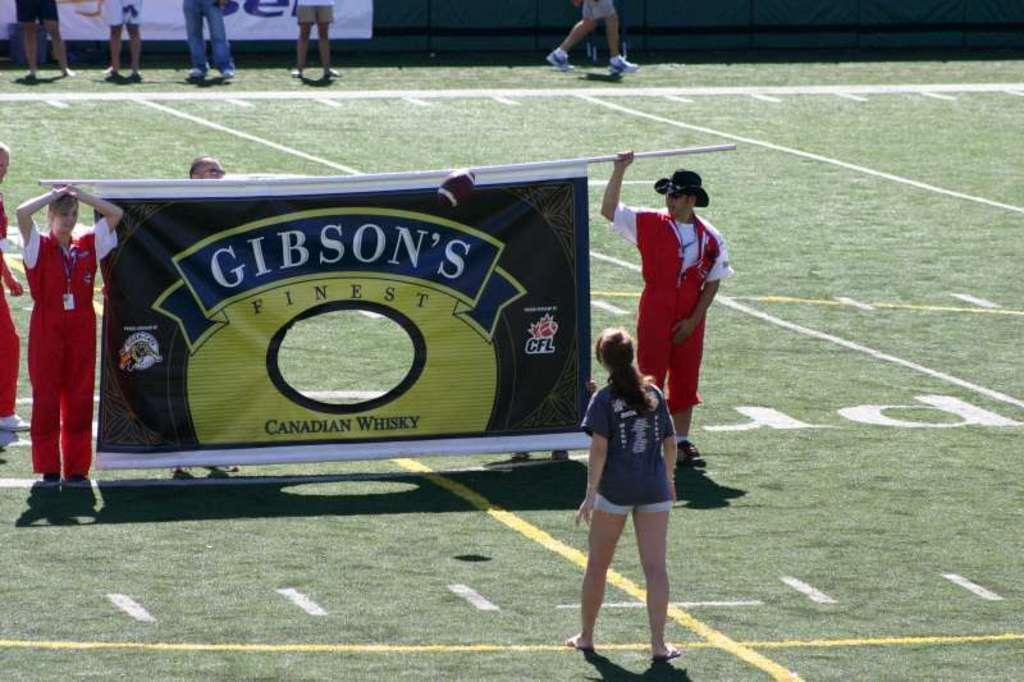What are the persons in the foreground of the image doing? The persons in the foreground of the image are holding a banner on the ground. Can you describe the background of the image? In the background of the image, there are persons visible, grass, advertisements, and fencing. What might be the purpose of the banner being held by the persons in the foreground? It is not clear from the image what the purpose of the banner is, but it could be related to an event or promotion. What type of surface is the banner being held on? The banner is being held on the ground. What type of rose can be seen growing on the paper in the image? There is no rose or paper present in the image; it features persons holding a banner on the ground with a grassy background and advertisements in the distance. 